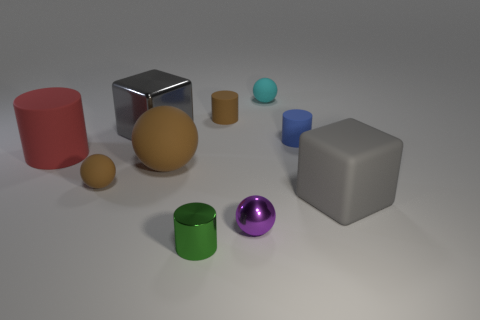Is there a big cube that has the same color as the big metallic object?
Offer a terse response. Yes. There is a big object that is the same color as the shiny block; what material is it?
Offer a terse response. Rubber. How many other objects are the same material as the small purple object?
Your answer should be compact. 2. Do the gray object that is right of the green cylinder and the gray object left of the metal cylinder have the same material?
Ensure brevity in your answer.  No. The large brown thing that is the same material as the small cyan ball is what shape?
Make the answer very short. Sphere. Is there any other thing that is the same color as the large rubber ball?
Your answer should be very brief. Yes. What number of large rubber spheres are there?
Your answer should be very brief. 1. The rubber thing that is in front of the large ball and right of the small green shiny cylinder has what shape?
Your response must be concise. Cube. What shape is the large matte object on the right side of the small brown object that is right of the gray thing on the left side of the small cyan object?
Your response must be concise. Cube. There is a object that is left of the metallic cylinder and behind the blue matte thing; what material is it made of?
Provide a short and direct response. Metal. 